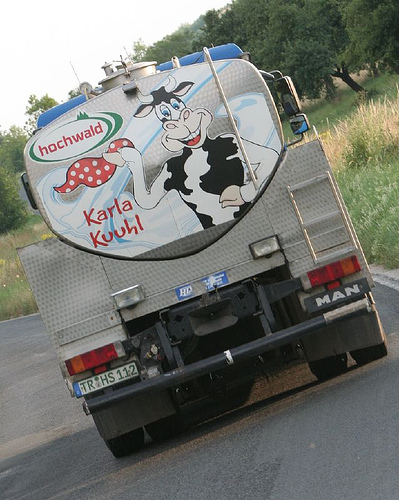<image>
Can you confirm if the cow is on the truck? Yes. Looking at the image, I can see the cow is positioned on top of the truck, with the truck providing support. 